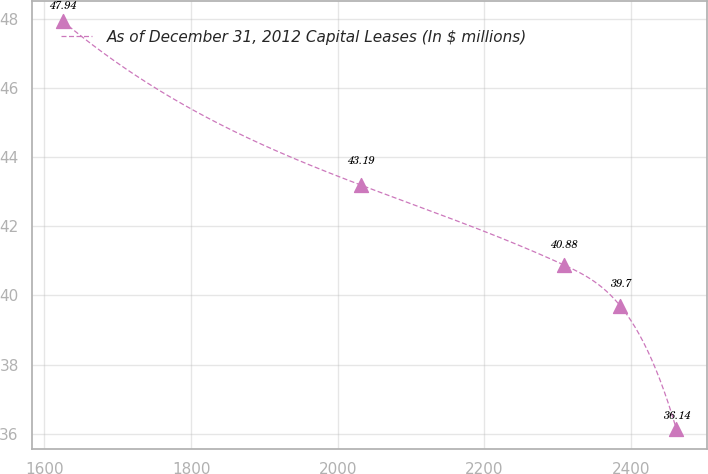Convert chart. <chart><loc_0><loc_0><loc_500><loc_500><line_chart><ecel><fcel>As of December 31, 2012 Capital Leases (In $ millions)<nl><fcel>1624.78<fcel>47.94<nl><fcel>2032.28<fcel>43.19<nl><fcel>2308.9<fcel>40.88<nl><fcel>2385.37<fcel>39.7<nl><fcel>2461.84<fcel>36.14<nl></chart> 